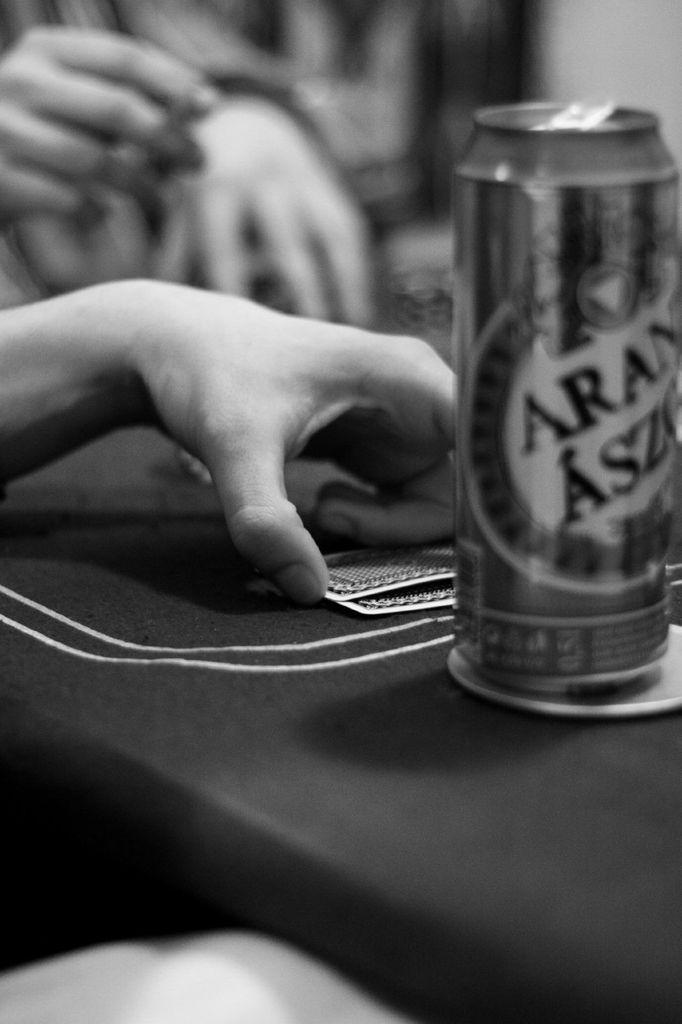What part of the human body is visible in the image? There is a human hand in the image. What objects are present in the image besides the hand? There are two cards and a cane in the image. Can you describe the background of the image? The background of the image is blurred. How many boats are visible in the image? There are no boats present in the image. What type of patch is being used to fix the cane in the image? There is no patch visible in the image, and the cane does not appear to be damaged or in need of repair. 